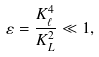Convert formula to latex. <formula><loc_0><loc_0><loc_500><loc_500>\varepsilon = \frac { K _ { \ell } ^ { 4 } } { K _ { L } ^ { 2 } } \ll 1 ,</formula> 